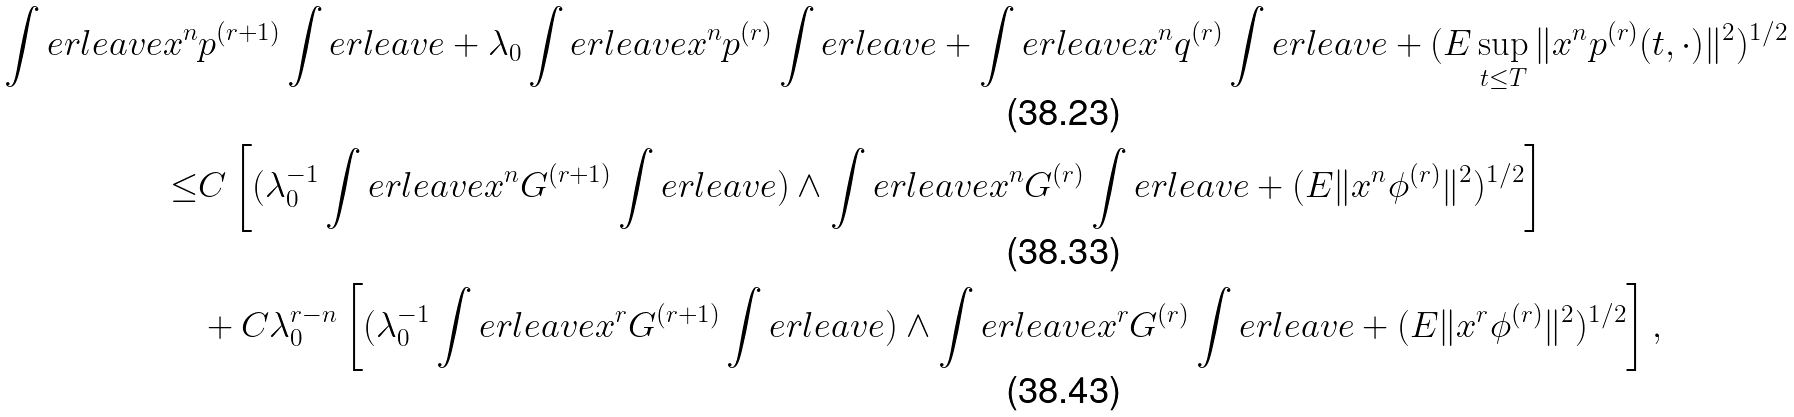<formula> <loc_0><loc_0><loc_500><loc_500>\int e r l e a v e x ^ { n } & p ^ { ( r + 1 ) } \int e r l e a v e + \lambda _ { 0 } \int e r l e a v e x ^ { n } p ^ { ( r ) } \int e r l e a v e + \int e r l e a v e x ^ { n } q ^ { ( r ) } \int e r l e a v e + ( E \sup _ { t \leq T } \| x ^ { n } p ^ { ( r ) } ( t , \cdot ) \| ^ { 2 } ) ^ { 1 / 2 } \\ \leq & C \left [ ( \lambda _ { 0 } ^ { - 1 } \int e r l e a v e x ^ { n } G ^ { ( r + 1 ) } \int e r l e a v e ) \wedge \int e r l e a v e x ^ { n } G ^ { ( r ) } \int e r l e a v e + ( E \| x ^ { n } \phi ^ { ( r ) } \| ^ { 2 } ) ^ { 1 / 2 } \right ] \\ & + C \lambda _ { 0 } ^ { r - n } \left [ ( \lambda _ { 0 } ^ { - 1 } \int e r l e a v e x ^ { r } G ^ { ( r + 1 ) } \int e r l e a v e ) \wedge \int e r l e a v e x ^ { r } G ^ { ( r ) } \int e r l e a v e + ( E \| x ^ { r } \phi ^ { ( r ) } \| ^ { 2 } ) ^ { 1 / 2 } \right ] ,</formula> 